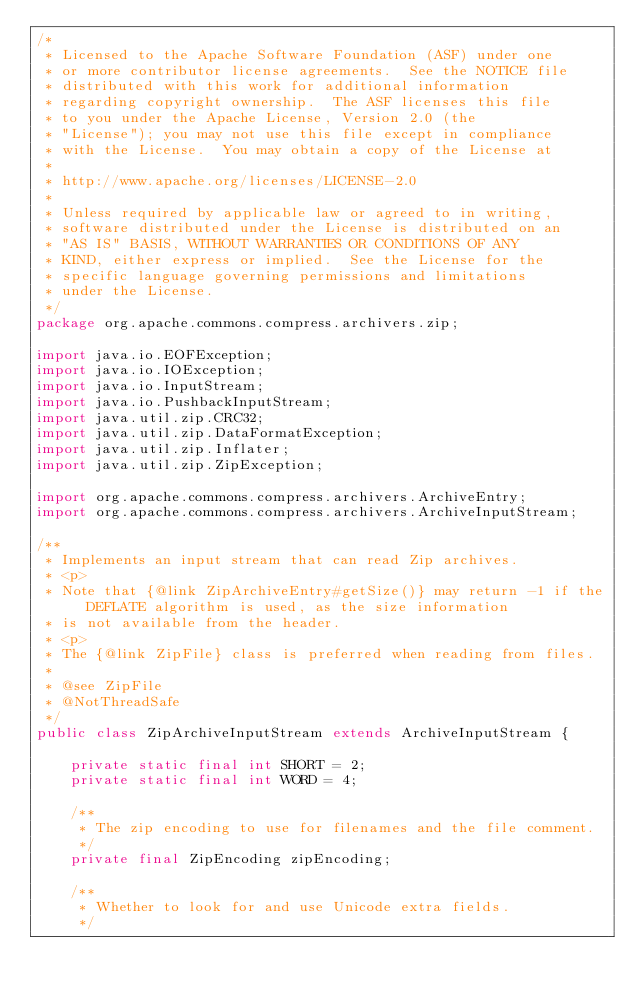Convert code to text. <code><loc_0><loc_0><loc_500><loc_500><_Java_>/*
 * Licensed to the Apache Software Foundation (ASF) under one
 * or more contributor license agreements.  See the NOTICE file
 * distributed with this work for additional information
 * regarding copyright ownership.  The ASF licenses this file
 * to you under the Apache License, Version 2.0 (the
 * "License"); you may not use this file except in compliance
 * with the License.  You may obtain a copy of the License at
 *
 * http://www.apache.org/licenses/LICENSE-2.0
 *
 * Unless required by applicable law or agreed to in writing,
 * software distributed under the License is distributed on an
 * "AS IS" BASIS, WITHOUT WARRANTIES OR CONDITIONS OF ANY
 * KIND, either express or implied.  See the License for the
 * specific language governing permissions and limitations
 * under the License.
 */
package org.apache.commons.compress.archivers.zip;

import java.io.EOFException;
import java.io.IOException;
import java.io.InputStream;
import java.io.PushbackInputStream;
import java.util.zip.CRC32;
import java.util.zip.DataFormatException;
import java.util.zip.Inflater;
import java.util.zip.ZipException;

import org.apache.commons.compress.archivers.ArchiveEntry;
import org.apache.commons.compress.archivers.ArchiveInputStream;

/**
 * Implements an input stream that can read Zip archives.
 * <p>
 * Note that {@link ZipArchiveEntry#getSize()} may return -1 if the DEFLATE algorithm is used, as the size information
 * is not available from the header.
 * <p>
 * The {@link ZipFile} class is preferred when reading from files.
 *  
 * @see ZipFile
 * @NotThreadSafe
 */
public class ZipArchiveInputStream extends ArchiveInputStream {

    private static final int SHORT = 2;
    private static final int WORD = 4;

    /**
     * The zip encoding to use for filenames and the file comment.
     */
    private final ZipEncoding zipEncoding;

    /**
     * Whether to look for and use Unicode extra fields.
     */</code> 